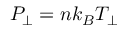Convert formula to latex. <formula><loc_0><loc_0><loc_500><loc_500>P _ { \perp } = n k _ { B } T _ { \perp }</formula> 